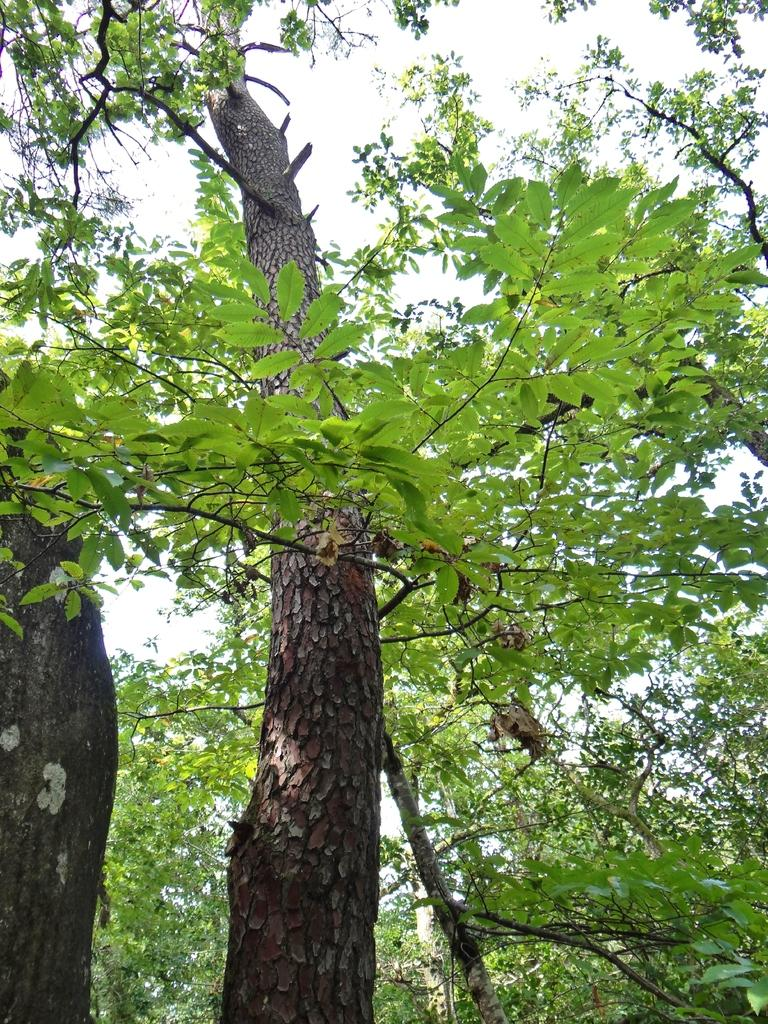What type of vegetation can be seen in the middle of the image? There are trees in the middle of the image. What is visible at the top of the image? The sky is visible at the top of the image. What type of pie is being cooked over the flame in the image? There is no pie or flame present in the image; it features trees and the sky. What type of stew is being prepared in the image? There is no stew or cooking activity present in the image; it features trees and the sky. 